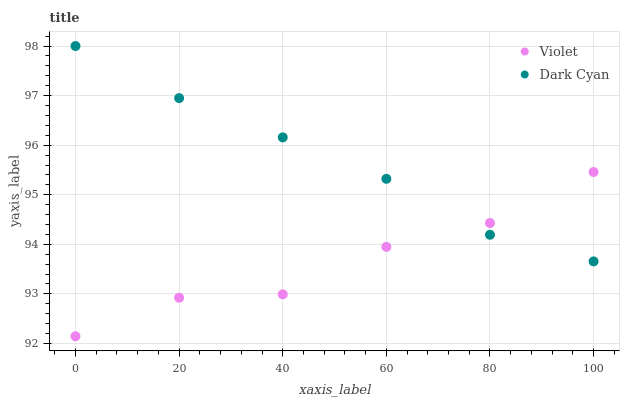Does Violet have the minimum area under the curve?
Answer yes or no. Yes. Does Dark Cyan have the maximum area under the curve?
Answer yes or no. Yes. Does Violet have the maximum area under the curve?
Answer yes or no. No. Is Dark Cyan the smoothest?
Answer yes or no. Yes. Is Violet the roughest?
Answer yes or no. Yes. Is Violet the smoothest?
Answer yes or no. No. Does Violet have the lowest value?
Answer yes or no. Yes. Does Dark Cyan have the highest value?
Answer yes or no. Yes. Does Violet have the highest value?
Answer yes or no. No. Does Violet intersect Dark Cyan?
Answer yes or no. Yes. Is Violet less than Dark Cyan?
Answer yes or no. No. Is Violet greater than Dark Cyan?
Answer yes or no. No. 